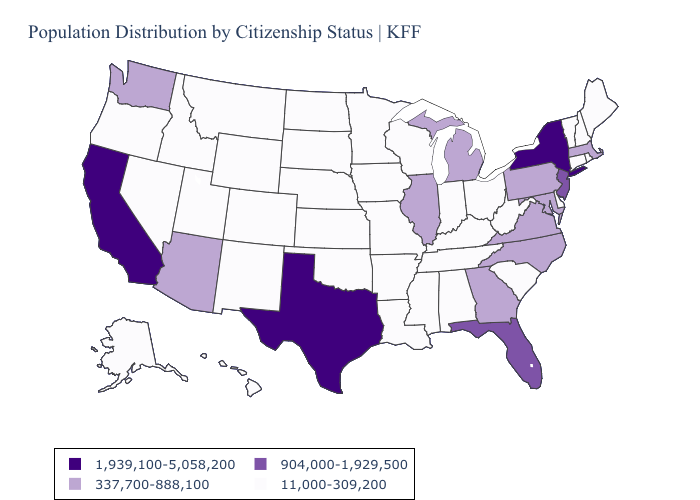Name the states that have a value in the range 1,939,100-5,058,200?
Answer briefly. California, New York, Texas. Does the first symbol in the legend represent the smallest category?
Short answer required. No. Name the states that have a value in the range 337,700-888,100?
Short answer required. Arizona, Georgia, Illinois, Maryland, Massachusetts, Michigan, North Carolina, Pennsylvania, Virginia, Washington. What is the lowest value in the Northeast?
Answer briefly. 11,000-309,200. What is the lowest value in the Northeast?
Write a very short answer. 11,000-309,200. Does Louisiana have a higher value than Maine?
Short answer required. No. Among the states that border Louisiana , does Texas have the lowest value?
Short answer required. No. Among the states that border New Jersey , which have the lowest value?
Quick response, please. Delaware. Does New Mexico have a lower value than Massachusetts?
Give a very brief answer. Yes. What is the value of Georgia?
Quick response, please. 337,700-888,100. What is the highest value in the South ?
Answer briefly. 1,939,100-5,058,200. Does New York have the same value as Maine?
Be succinct. No. Which states have the lowest value in the USA?
Give a very brief answer. Alabama, Alaska, Arkansas, Colorado, Connecticut, Delaware, Hawaii, Idaho, Indiana, Iowa, Kansas, Kentucky, Louisiana, Maine, Minnesota, Mississippi, Missouri, Montana, Nebraska, Nevada, New Hampshire, New Mexico, North Dakota, Ohio, Oklahoma, Oregon, Rhode Island, South Carolina, South Dakota, Tennessee, Utah, Vermont, West Virginia, Wisconsin, Wyoming. Name the states that have a value in the range 904,000-1,929,500?
Keep it brief. Florida, New Jersey. 